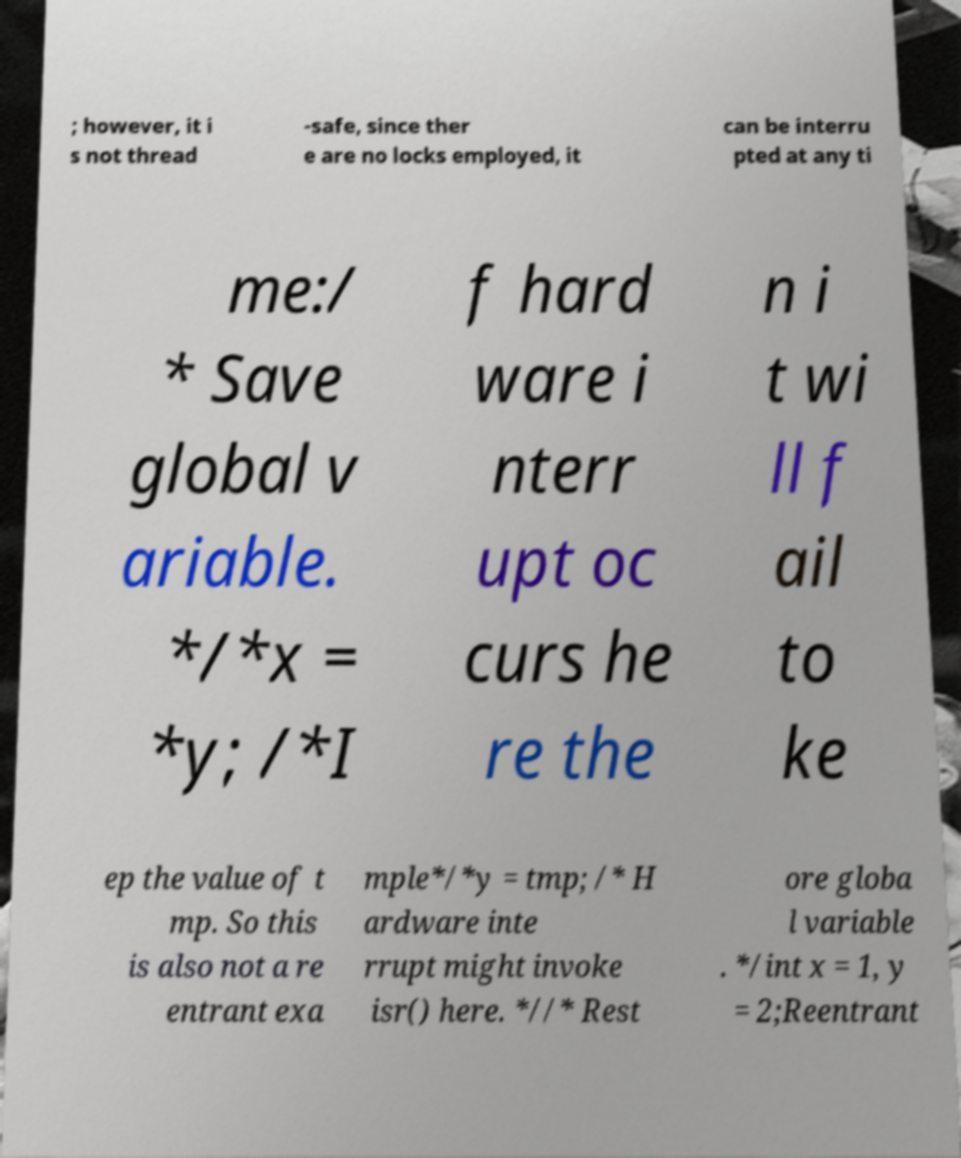I need the written content from this picture converted into text. Can you do that? ; however, it i s not thread -safe, since ther e are no locks employed, it can be interru pted at any ti me:/ * Save global v ariable. */*x = *y; /*I f hard ware i nterr upt oc curs he re the n i t wi ll f ail to ke ep the value of t mp. So this is also not a re entrant exa mple*/*y = tmp; /* H ardware inte rrupt might invoke isr() here. *//* Rest ore globa l variable . */int x = 1, y = 2;Reentrant 